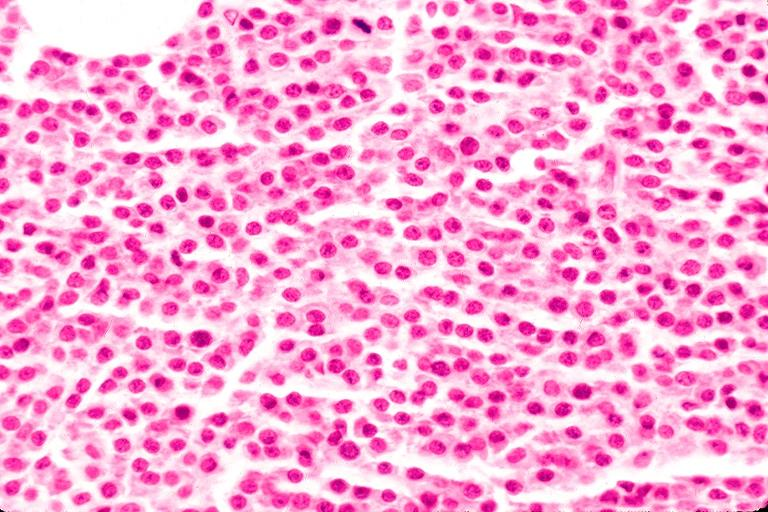does this image show multiple myeloma?
Answer the question using a single word or phrase. Yes 